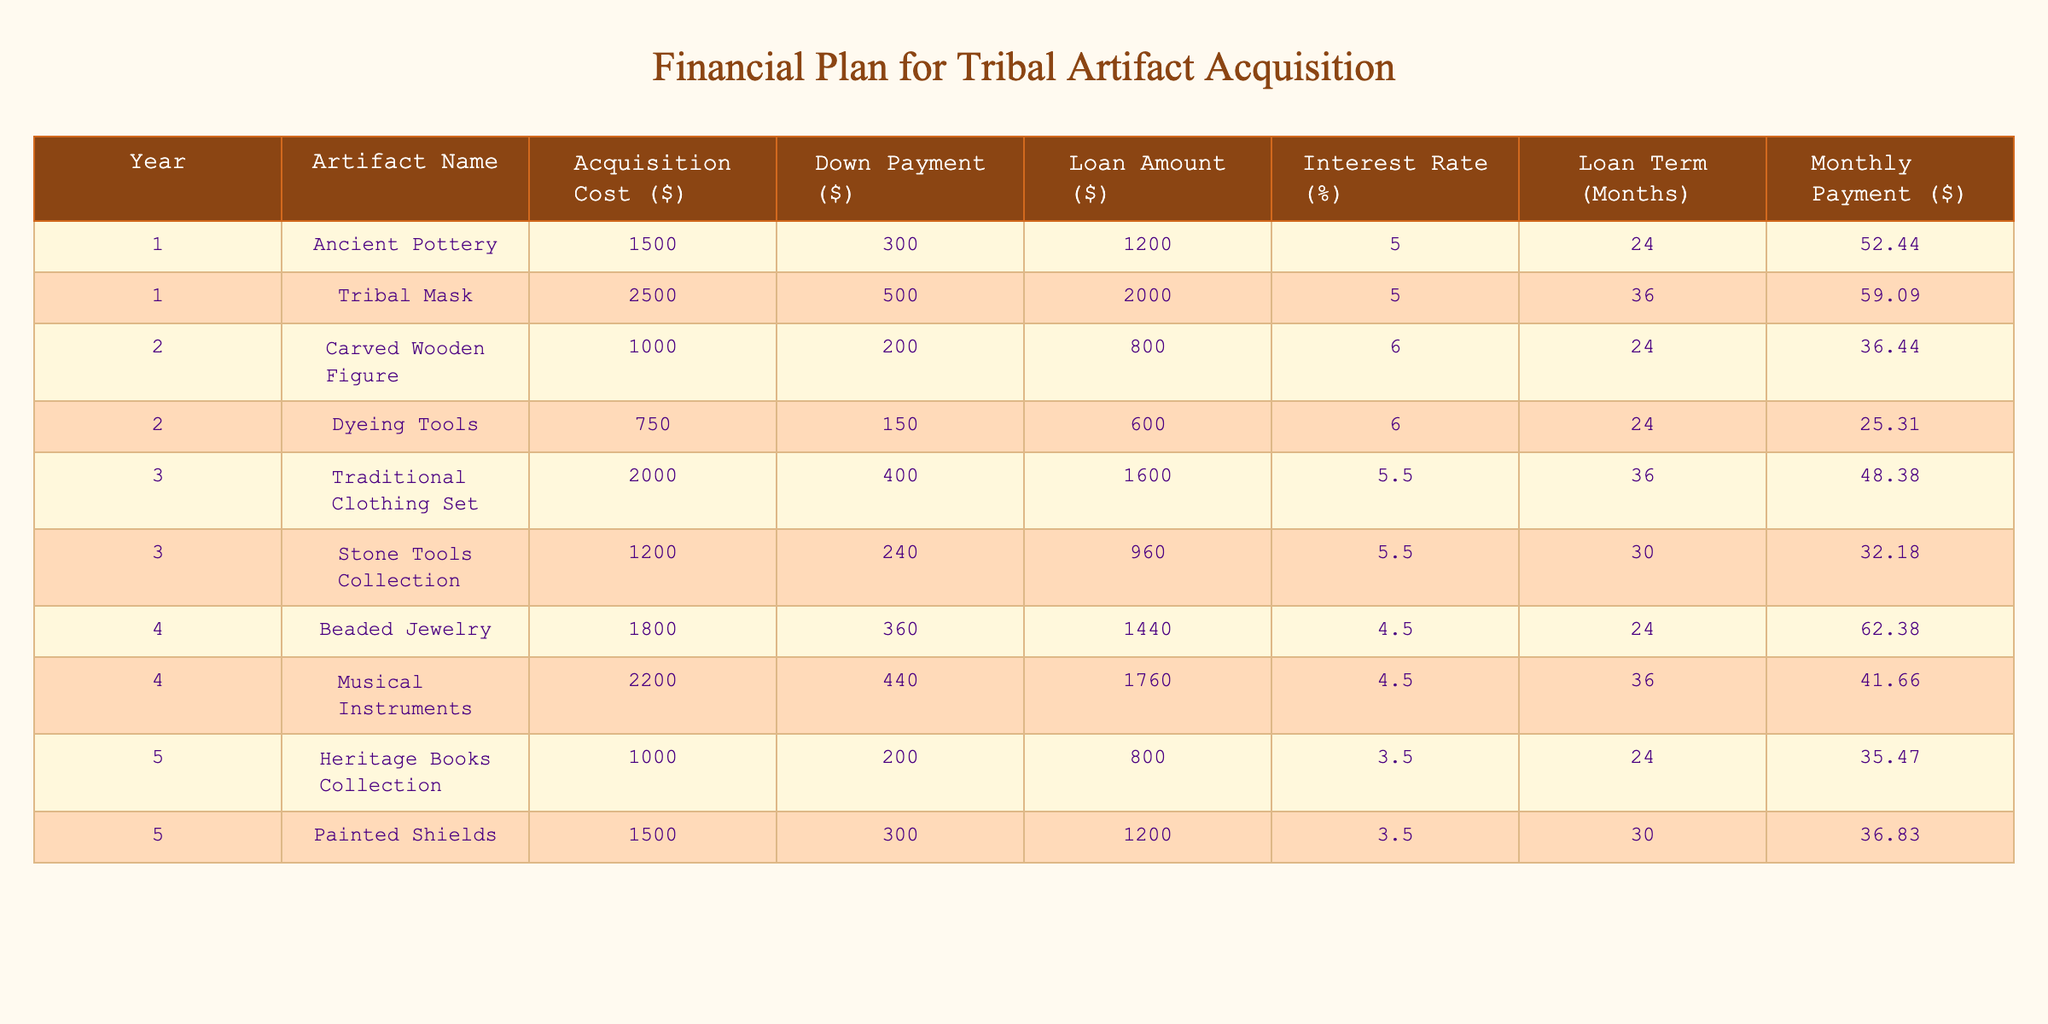What is the acquisition cost of the Tribal Mask? The Tribal Mask listed in Year 1 has an acquisition cost of $2500. You can find this value directly in the table under the "Acquisition Cost ($)" column for the appropriate row.
Answer: 2500 What is the monthly payment for the Beaded Jewelry? In Year 4, the Beaded Jewelry is associated with a monthly payment of $62.38, which is directly stated in the "Monthly Payment ($)" column of that row in the table.
Answer: 62.38 Which artifact has the highest loan amount and what is it? Looking through the "Loan Amount ($)" column, the highest value is $2000 for the Tribal Mask in Year 1. This is determined by comparing all values in the column to find the maximum.
Answer: Tribal Mask, 2000 What is the total acquisition cost for Year 2 artifacts? The acquisition costs for Year 2 artifacts are $1000 for the Carved Wooden Figure and $750 for the Dyeing Tools. Adding these together gives a total of $1000 + $750 = $1750.
Answer: 1750 Is the interest rate for the Painted Shields lower than that for the Heritage Books Collection? The Painted Shields have an interest rate of 3.5%, while the Heritage Books Collection has an interest rate of 3.5% as well. Therefore, the statement is false because they are equal.
Answer: No What is the average monthly payment for Year 3 artifacts? The monthly payments for Year 3 artifacts are $48.38 for Traditional Clothing Set and $32.18 for Stone Tools Collection. Summing these gives $48.38 + $32.18 = $80.56. Dividing this sum by 2 (since there are two artifacts) results in an average of $40.28.
Answer: 40.28 Which year has the lowest acquisition cost in total? The acquisition costs for each year are: Year 1: $1500 + $2500 = $4000, Year 2: $1000 + $750 = $1750, Year 3: $2000 + $1200 = $3200, Year 4: $1800 + $2200 = $4000, and Year 5: $1000 + $1500 = $2500. Year 2 has the lowest total acquisition cost of $1750.
Answer: Year 2 What is the total loan amount for all artifacts acquired over five years? The loan amounts for the artifacts are: Year 1: $1200 + $2000 = $3200, Year 2: $800 + $600 = $1400, Year 3: $1600 + $960 = $2560, Year 4: $1440 + $1760 = $3200, Year 5: $800 + $1200 = $2000. Adding all these gives $3200 + $1400 + $2560 + $3200 + $2000 = $12360.
Answer: 12360 